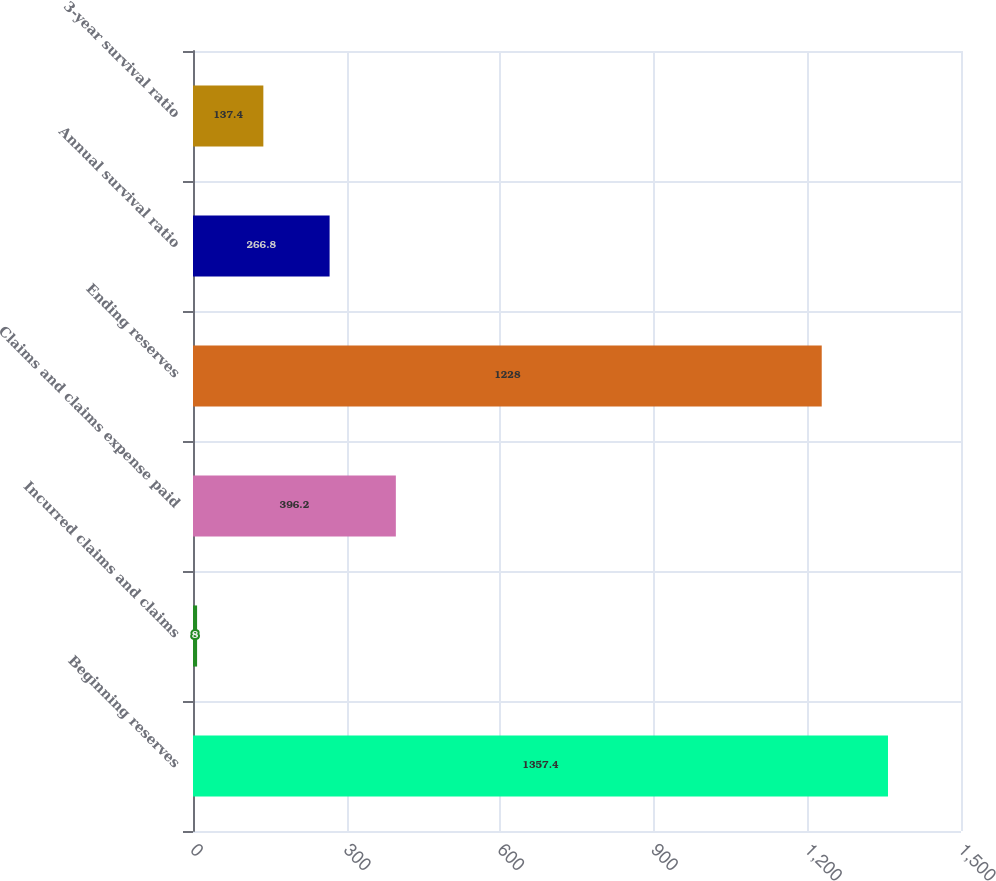Convert chart to OTSL. <chart><loc_0><loc_0><loc_500><loc_500><bar_chart><fcel>Beginning reserves<fcel>Incurred claims and claims<fcel>Claims and claims expense paid<fcel>Ending reserves<fcel>Annual survival ratio<fcel>3-year survival ratio<nl><fcel>1357.4<fcel>8<fcel>396.2<fcel>1228<fcel>266.8<fcel>137.4<nl></chart> 